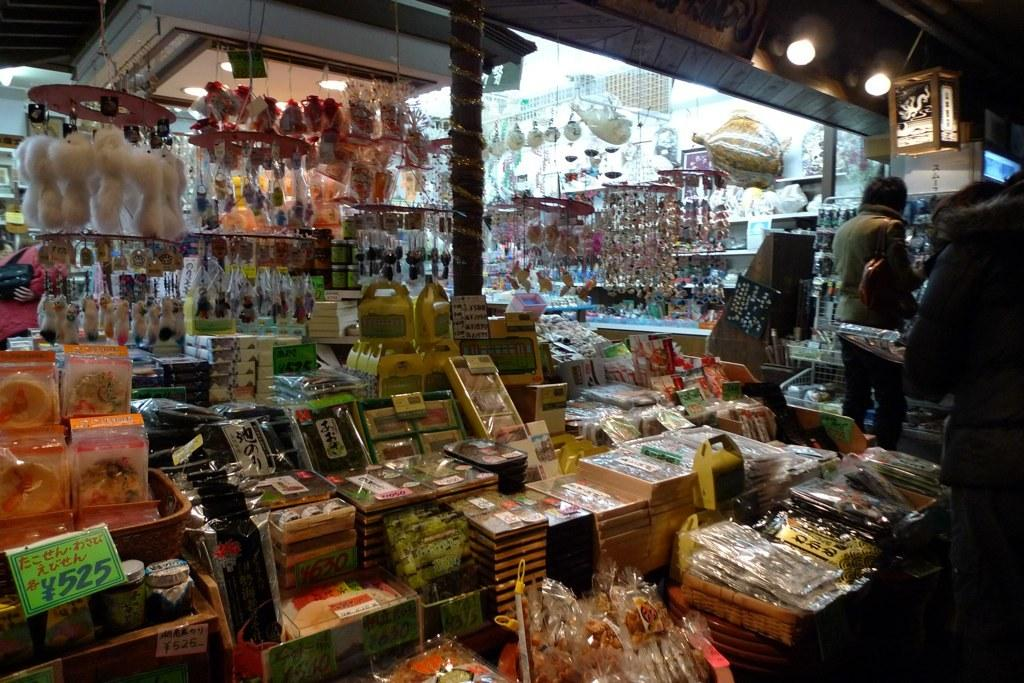What type of store is shown in the image? There is a gallery store in the image. What items can be found inside the store? The store is full of keychains and toys. Are there any people near the store? Yes, there are people standing near the store. What can be seen at the top of the store? There are two lights visible at the top of the store. What type of honey is being sold at the store in the image? There is no honey being sold at the store in the image; it is full of keychains and toys. 